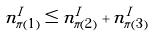<formula> <loc_0><loc_0><loc_500><loc_500>n ^ { I } _ { \pi ( 1 ) } \leq n ^ { I } _ { \pi ( 2 ) } + n ^ { I } _ { \pi ( 3 ) }</formula> 